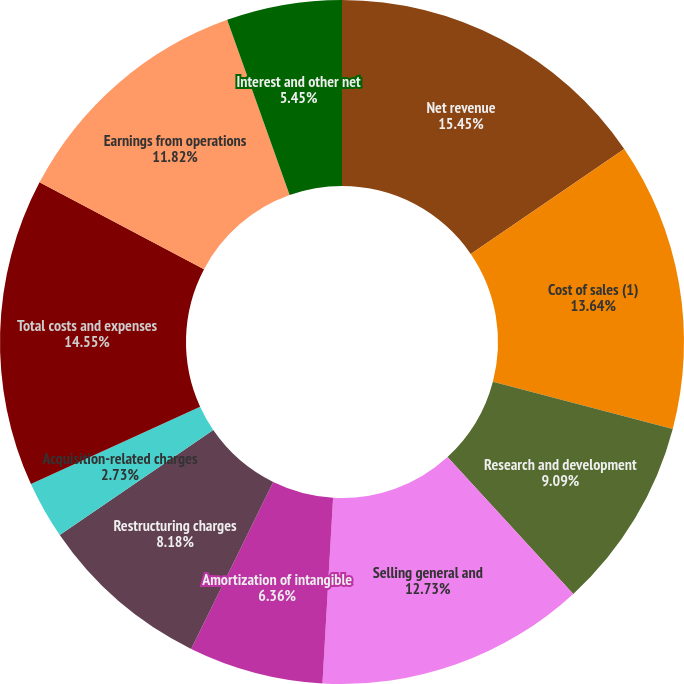Convert chart. <chart><loc_0><loc_0><loc_500><loc_500><pie_chart><fcel>Net revenue<fcel>Cost of sales (1)<fcel>Research and development<fcel>Selling general and<fcel>Amortization of intangible<fcel>Restructuring charges<fcel>Acquisition-related charges<fcel>Total costs and expenses<fcel>Earnings from operations<fcel>Interest and other net<nl><fcel>15.45%<fcel>13.64%<fcel>9.09%<fcel>12.73%<fcel>6.36%<fcel>8.18%<fcel>2.73%<fcel>14.55%<fcel>11.82%<fcel>5.45%<nl></chart> 